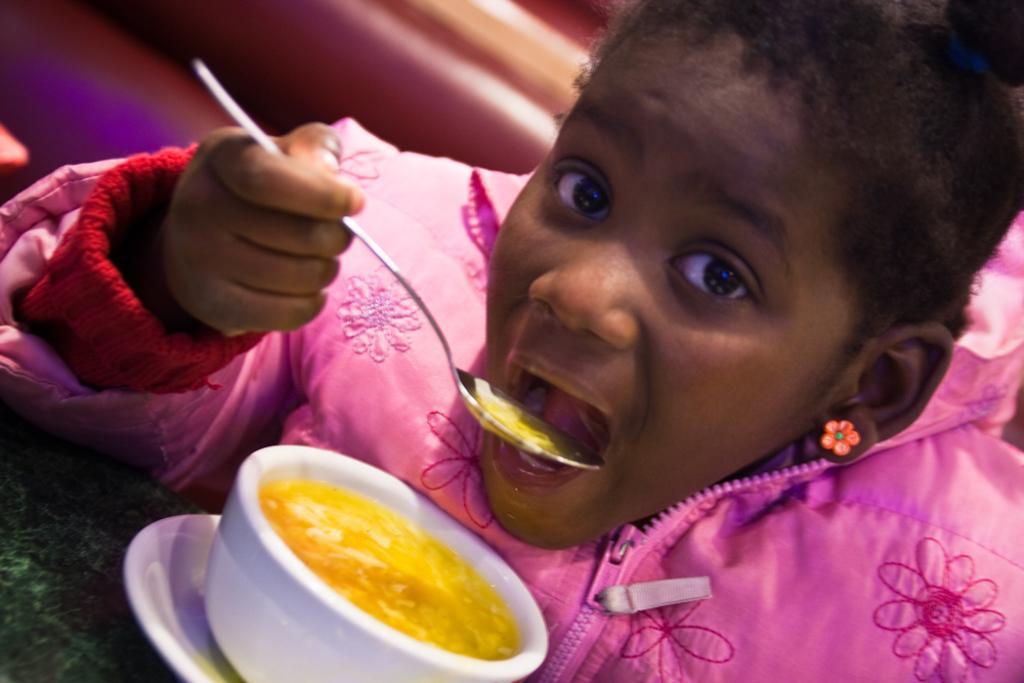How would you summarize this image in a sentence or two? This girl is highlighted in this picture. She is holding a spoon. In-front of this girl there is a cup with a saucer. In a cup there is a food. I think she might be eating her food, as we can see this spoon is near to her mouth. This girl wore pink jacket and earrings. 